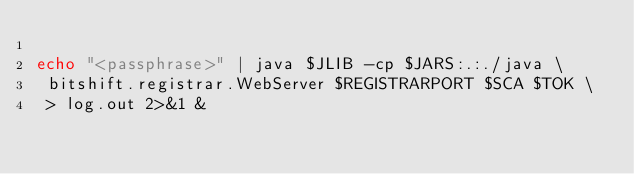<code> <loc_0><loc_0><loc_500><loc_500><_Bash_>
echo "<passphrase>" | java $JLIB -cp $JARS:.:./java \
 bitshift.registrar.WebServer $REGISTRARPORT $SCA $TOK \
 > log.out 2>&1 &
</code> 